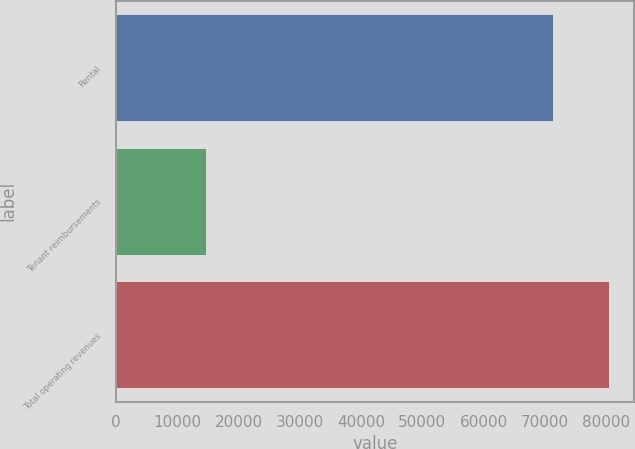Convert chart. <chart><loc_0><loc_0><loc_500><loc_500><bar_chart><fcel>Rental<fcel>Tenant reimbursements<fcel>Total operating revenues<nl><fcel>71314<fcel>14622<fcel>80472<nl></chart> 